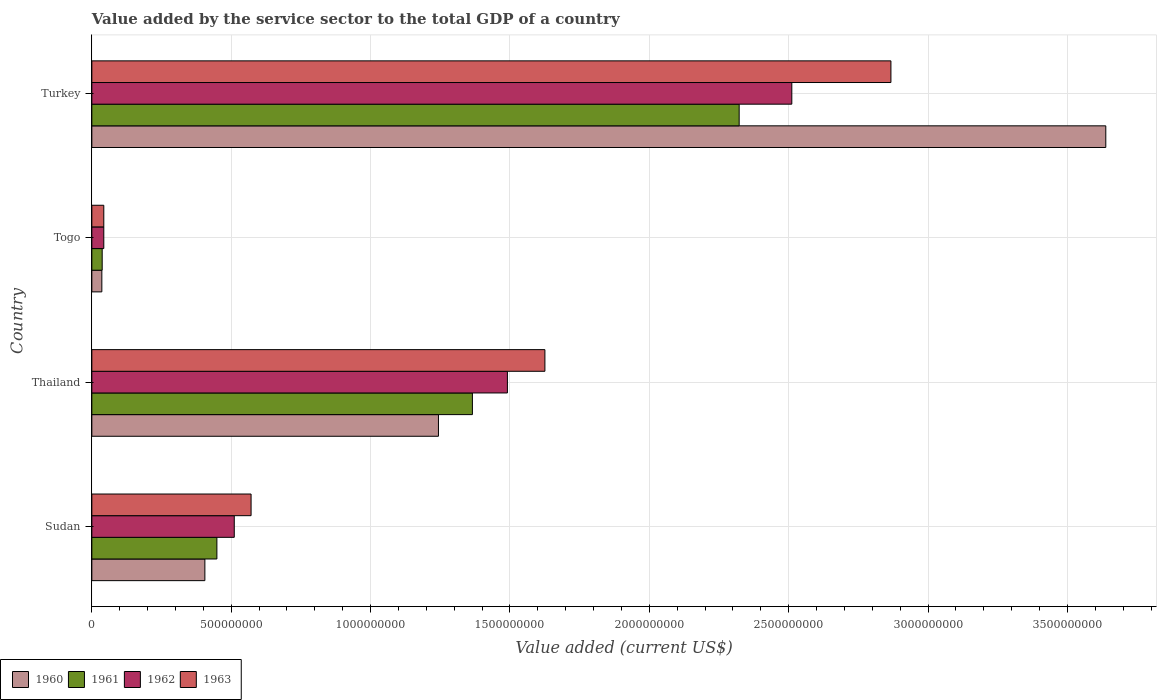How many groups of bars are there?
Provide a succinct answer. 4. Are the number of bars per tick equal to the number of legend labels?
Offer a very short reply. Yes. Are the number of bars on each tick of the Y-axis equal?
Keep it short and to the point. Yes. How many bars are there on the 3rd tick from the top?
Your answer should be compact. 4. How many bars are there on the 1st tick from the bottom?
Your answer should be very brief. 4. What is the label of the 3rd group of bars from the top?
Offer a very short reply. Thailand. What is the value added by the service sector to the total GDP in 1962 in Sudan?
Ensure brevity in your answer.  5.11e+08. Across all countries, what is the maximum value added by the service sector to the total GDP in 1962?
Ensure brevity in your answer.  2.51e+09. Across all countries, what is the minimum value added by the service sector to the total GDP in 1963?
Give a very brief answer. 4.29e+07. In which country was the value added by the service sector to the total GDP in 1961 minimum?
Offer a very short reply. Togo. What is the total value added by the service sector to the total GDP in 1963 in the graph?
Your response must be concise. 5.11e+09. What is the difference between the value added by the service sector to the total GDP in 1961 in Togo and that in Turkey?
Offer a terse response. -2.29e+09. What is the difference between the value added by the service sector to the total GDP in 1962 in Togo and the value added by the service sector to the total GDP in 1960 in Thailand?
Ensure brevity in your answer.  -1.20e+09. What is the average value added by the service sector to the total GDP in 1962 per country?
Make the answer very short. 1.14e+09. What is the difference between the value added by the service sector to the total GDP in 1963 and value added by the service sector to the total GDP in 1961 in Thailand?
Ensure brevity in your answer.  2.60e+08. In how many countries, is the value added by the service sector to the total GDP in 1961 greater than 1200000000 US$?
Give a very brief answer. 2. What is the ratio of the value added by the service sector to the total GDP in 1961 in Thailand to that in Togo?
Your response must be concise. 36.8. Is the difference between the value added by the service sector to the total GDP in 1963 in Sudan and Togo greater than the difference between the value added by the service sector to the total GDP in 1961 in Sudan and Togo?
Keep it short and to the point. Yes. What is the difference between the highest and the second highest value added by the service sector to the total GDP in 1961?
Keep it short and to the point. 9.57e+08. What is the difference between the highest and the lowest value added by the service sector to the total GDP in 1960?
Your answer should be very brief. 3.60e+09. Are the values on the major ticks of X-axis written in scientific E-notation?
Your answer should be compact. No. Does the graph contain grids?
Offer a terse response. Yes. How many legend labels are there?
Your response must be concise. 4. How are the legend labels stacked?
Offer a very short reply. Horizontal. What is the title of the graph?
Offer a very short reply. Value added by the service sector to the total GDP of a country. What is the label or title of the X-axis?
Keep it short and to the point. Value added (current US$). What is the Value added (current US$) in 1960 in Sudan?
Your answer should be very brief. 4.06e+08. What is the Value added (current US$) of 1961 in Sudan?
Your answer should be compact. 4.49e+08. What is the Value added (current US$) of 1962 in Sudan?
Give a very brief answer. 5.11e+08. What is the Value added (current US$) of 1963 in Sudan?
Offer a terse response. 5.71e+08. What is the Value added (current US$) in 1960 in Thailand?
Keep it short and to the point. 1.24e+09. What is the Value added (current US$) of 1961 in Thailand?
Ensure brevity in your answer.  1.37e+09. What is the Value added (current US$) of 1962 in Thailand?
Your response must be concise. 1.49e+09. What is the Value added (current US$) of 1963 in Thailand?
Offer a terse response. 1.63e+09. What is the Value added (current US$) of 1960 in Togo?
Your answer should be compact. 3.59e+07. What is the Value added (current US$) in 1961 in Togo?
Your response must be concise. 3.71e+07. What is the Value added (current US$) in 1962 in Togo?
Keep it short and to the point. 4.29e+07. What is the Value added (current US$) of 1963 in Togo?
Offer a terse response. 4.29e+07. What is the Value added (current US$) of 1960 in Turkey?
Ensure brevity in your answer.  3.64e+09. What is the Value added (current US$) in 1961 in Turkey?
Give a very brief answer. 2.32e+09. What is the Value added (current US$) of 1962 in Turkey?
Ensure brevity in your answer.  2.51e+09. What is the Value added (current US$) in 1963 in Turkey?
Keep it short and to the point. 2.87e+09. Across all countries, what is the maximum Value added (current US$) in 1960?
Give a very brief answer. 3.64e+09. Across all countries, what is the maximum Value added (current US$) in 1961?
Offer a very short reply. 2.32e+09. Across all countries, what is the maximum Value added (current US$) of 1962?
Your answer should be compact. 2.51e+09. Across all countries, what is the maximum Value added (current US$) of 1963?
Your answer should be very brief. 2.87e+09. Across all countries, what is the minimum Value added (current US$) in 1960?
Ensure brevity in your answer.  3.59e+07. Across all countries, what is the minimum Value added (current US$) in 1961?
Offer a very short reply. 3.71e+07. Across all countries, what is the minimum Value added (current US$) of 1962?
Provide a succinct answer. 4.29e+07. Across all countries, what is the minimum Value added (current US$) of 1963?
Your answer should be compact. 4.29e+07. What is the total Value added (current US$) in 1960 in the graph?
Your response must be concise. 5.32e+09. What is the total Value added (current US$) in 1961 in the graph?
Keep it short and to the point. 4.17e+09. What is the total Value added (current US$) of 1962 in the graph?
Provide a succinct answer. 4.56e+09. What is the total Value added (current US$) in 1963 in the graph?
Give a very brief answer. 5.11e+09. What is the difference between the Value added (current US$) of 1960 in Sudan and that in Thailand?
Give a very brief answer. -8.38e+08. What is the difference between the Value added (current US$) of 1961 in Sudan and that in Thailand?
Provide a short and direct response. -9.17e+08. What is the difference between the Value added (current US$) in 1962 in Sudan and that in Thailand?
Ensure brevity in your answer.  -9.80e+08. What is the difference between the Value added (current US$) of 1963 in Sudan and that in Thailand?
Provide a short and direct response. -1.05e+09. What is the difference between the Value added (current US$) in 1960 in Sudan and that in Togo?
Provide a short and direct response. 3.70e+08. What is the difference between the Value added (current US$) of 1961 in Sudan and that in Togo?
Your answer should be compact. 4.11e+08. What is the difference between the Value added (current US$) in 1962 in Sudan and that in Togo?
Your response must be concise. 4.68e+08. What is the difference between the Value added (current US$) of 1963 in Sudan and that in Togo?
Provide a succinct answer. 5.28e+08. What is the difference between the Value added (current US$) in 1960 in Sudan and that in Turkey?
Your response must be concise. -3.23e+09. What is the difference between the Value added (current US$) of 1961 in Sudan and that in Turkey?
Make the answer very short. -1.87e+09. What is the difference between the Value added (current US$) in 1962 in Sudan and that in Turkey?
Your answer should be compact. -2.00e+09. What is the difference between the Value added (current US$) of 1963 in Sudan and that in Turkey?
Provide a succinct answer. -2.30e+09. What is the difference between the Value added (current US$) in 1960 in Thailand and that in Togo?
Your response must be concise. 1.21e+09. What is the difference between the Value added (current US$) of 1961 in Thailand and that in Togo?
Provide a succinct answer. 1.33e+09. What is the difference between the Value added (current US$) of 1962 in Thailand and that in Togo?
Your response must be concise. 1.45e+09. What is the difference between the Value added (current US$) in 1963 in Thailand and that in Togo?
Your response must be concise. 1.58e+09. What is the difference between the Value added (current US$) in 1960 in Thailand and that in Turkey?
Provide a short and direct response. -2.39e+09. What is the difference between the Value added (current US$) of 1961 in Thailand and that in Turkey?
Offer a very short reply. -9.57e+08. What is the difference between the Value added (current US$) of 1962 in Thailand and that in Turkey?
Your response must be concise. -1.02e+09. What is the difference between the Value added (current US$) of 1963 in Thailand and that in Turkey?
Make the answer very short. -1.24e+09. What is the difference between the Value added (current US$) of 1960 in Togo and that in Turkey?
Offer a very short reply. -3.60e+09. What is the difference between the Value added (current US$) in 1961 in Togo and that in Turkey?
Ensure brevity in your answer.  -2.29e+09. What is the difference between the Value added (current US$) of 1962 in Togo and that in Turkey?
Make the answer very short. -2.47e+09. What is the difference between the Value added (current US$) in 1963 in Togo and that in Turkey?
Provide a short and direct response. -2.82e+09. What is the difference between the Value added (current US$) of 1960 in Sudan and the Value added (current US$) of 1961 in Thailand?
Your response must be concise. -9.60e+08. What is the difference between the Value added (current US$) in 1960 in Sudan and the Value added (current US$) in 1962 in Thailand?
Your answer should be compact. -1.09e+09. What is the difference between the Value added (current US$) of 1960 in Sudan and the Value added (current US$) of 1963 in Thailand?
Offer a terse response. -1.22e+09. What is the difference between the Value added (current US$) in 1961 in Sudan and the Value added (current US$) in 1962 in Thailand?
Your answer should be compact. -1.04e+09. What is the difference between the Value added (current US$) in 1961 in Sudan and the Value added (current US$) in 1963 in Thailand?
Provide a succinct answer. -1.18e+09. What is the difference between the Value added (current US$) of 1962 in Sudan and the Value added (current US$) of 1963 in Thailand?
Provide a succinct answer. -1.11e+09. What is the difference between the Value added (current US$) of 1960 in Sudan and the Value added (current US$) of 1961 in Togo?
Provide a succinct answer. 3.68e+08. What is the difference between the Value added (current US$) of 1960 in Sudan and the Value added (current US$) of 1962 in Togo?
Ensure brevity in your answer.  3.63e+08. What is the difference between the Value added (current US$) in 1960 in Sudan and the Value added (current US$) in 1963 in Togo?
Offer a terse response. 3.63e+08. What is the difference between the Value added (current US$) of 1961 in Sudan and the Value added (current US$) of 1962 in Togo?
Provide a short and direct response. 4.06e+08. What is the difference between the Value added (current US$) of 1961 in Sudan and the Value added (current US$) of 1963 in Togo?
Offer a terse response. 4.06e+08. What is the difference between the Value added (current US$) in 1962 in Sudan and the Value added (current US$) in 1963 in Togo?
Your response must be concise. 4.68e+08. What is the difference between the Value added (current US$) of 1960 in Sudan and the Value added (current US$) of 1961 in Turkey?
Keep it short and to the point. -1.92e+09. What is the difference between the Value added (current US$) in 1960 in Sudan and the Value added (current US$) in 1962 in Turkey?
Keep it short and to the point. -2.11e+09. What is the difference between the Value added (current US$) of 1960 in Sudan and the Value added (current US$) of 1963 in Turkey?
Your response must be concise. -2.46e+09. What is the difference between the Value added (current US$) in 1961 in Sudan and the Value added (current US$) in 1962 in Turkey?
Offer a very short reply. -2.06e+09. What is the difference between the Value added (current US$) of 1961 in Sudan and the Value added (current US$) of 1963 in Turkey?
Offer a terse response. -2.42e+09. What is the difference between the Value added (current US$) in 1962 in Sudan and the Value added (current US$) in 1963 in Turkey?
Provide a short and direct response. -2.36e+09. What is the difference between the Value added (current US$) of 1960 in Thailand and the Value added (current US$) of 1961 in Togo?
Provide a succinct answer. 1.21e+09. What is the difference between the Value added (current US$) of 1960 in Thailand and the Value added (current US$) of 1962 in Togo?
Your answer should be compact. 1.20e+09. What is the difference between the Value added (current US$) of 1960 in Thailand and the Value added (current US$) of 1963 in Togo?
Keep it short and to the point. 1.20e+09. What is the difference between the Value added (current US$) in 1961 in Thailand and the Value added (current US$) in 1962 in Togo?
Ensure brevity in your answer.  1.32e+09. What is the difference between the Value added (current US$) of 1961 in Thailand and the Value added (current US$) of 1963 in Togo?
Your answer should be compact. 1.32e+09. What is the difference between the Value added (current US$) in 1962 in Thailand and the Value added (current US$) in 1963 in Togo?
Keep it short and to the point. 1.45e+09. What is the difference between the Value added (current US$) of 1960 in Thailand and the Value added (current US$) of 1961 in Turkey?
Your answer should be very brief. -1.08e+09. What is the difference between the Value added (current US$) in 1960 in Thailand and the Value added (current US$) in 1962 in Turkey?
Provide a succinct answer. -1.27e+09. What is the difference between the Value added (current US$) of 1960 in Thailand and the Value added (current US$) of 1963 in Turkey?
Your response must be concise. -1.62e+09. What is the difference between the Value added (current US$) of 1961 in Thailand and the Value added (current US$) of 1962 in Turkey?
Offer a very short reply. -1.15e+09. What is the difference between the Value added (current US$) in 1961 in Thailand and the Value added (current US$) in 1963 in Turkey?
Keep it short and to the point. -1.50e+09. What is the difference between the Value added (current US$) of 1962 in Thailand and the Value added (current US$) of 1963 in Turkey?
Your response must be concise. -1.38e+09. What is the difference between the Value added (current US$) of 1960 in Togo and the Value added (current US$) of 1961 in Turkey?
Keep it short and to the point. -2.29e+09. What is the difference between the Value added (current US$) in 1960 in Togo and the Value added (current US$) in 1962 in Turkey?
Provide a short and direct response. -2.48e+09. What is the difference between the Value added (current US$) of 1960 in Togo and the Value added (current US$) of 1963 in Turkey?
Ensure brevity in your answer.  -2.83e+09. What is the difference between the Value added (current US$) of 1961 in Togo and the Value added (current US$) of 1962 in Turkey?
Make the answer very short. -2.47e+09. What is the difference between the Value added (current US$) of 1961 in Togo and the Value added (current US$) of 1963 in Turkey?
Your answer should be compact. -2.83e+09. What is the difference between the Value added (current US$) in 1962 in Togo and the Value added (current US$) in 1963 in Turkey?
Your answer should be very brief. -2.82e+09. What is the average Value added (current US$) of 1960 per country?
Offer a very short reply. 1.33e+09. What is the average Value added (current US$) of 1961 per country?
Your response must be concise. 1.04e+09. What is the average Value added (current US$) in 1962 per country?
Make the answer very short. 1.14e+09. What is the average Value added (current US$) of 1963 per country?
Offer a terse response. 1.28e+09. What is the difference between the Value added (current US$) of 1960 and Value added (current US$) of 1961 in Sudan?
Offer a terse response. -4.31e+07. What is the difference between the Value added (current US$) in 1960 and Value added (current US$) in 1962 in Sudan?
Your answer should be very brief. -1.05e+08. What is the difference between the Value added (current US$) of 1960 and Value added (current US$) of 1963 in Sudan?
Provide a succinct answer. -1.66e+08. What is the difference between the Value added (current US$) in 1961 and Value added (current US$) in 1962 in Sudan?
Your response must be concise. -6.23e+07. What is the difference between the Value added (current US$) of 1961 and Value added (current US$) of 1963 in Sudan?
Offer a terse response. -1.23e+08. What is the difference between the Value added (current US$) of 1962 and Value added (current US$) of 1963 in Sudan?
Keep it short and to the point. -6.03e+07. What is the difference between the Value added (current US$) of 1960 and Value added (current US$) of 1961 in Thailand?
Give a very brief answer. -1.22e+08. What is the difference between the Value added (current US$) of 1960 and Value added (current US$) of 1962 in Thailand?
Keep it short and to the point. -2.47e+08. What is the difference between the Value added (current US$) in 1960 and Value added (current US$) in 1963 in Thailand?
Offer a very short reply. -3.82e+08. What is the difference between the Value added (current US$) in 1961 and Value added (current US$) in 1962 in Thailand?
Keep it short and to the point. -1.26e+08. What is the difference between the Value added (current US$) in 1961 and Value added (current US$) in 1963 in Thailand?
Your answer should be very brief. -2.60e+08. What is the difference between the Value added (current US$) of 1962 and Value added (current US$) of 1963 in Thailand?
Your answer should be compact. -1.35e+08. What is the difference between the Value added (current US$) in 1960 and Value added (current US$) in 1961 in Togo?
Ensure brevity in your answer.  -1.21e+06. What is the difference between the Value added (current US$) in 1960 and Value added (current US$) in 1962 in Togo?
Offer a terse response. -6.96e+06. What is the difference between the Value added (current US$) of 1960 and Value added (current US$) of 1963 in Togo?
Ensure brevity in your answer.  -6.96e+06. What is the difference between the Value added (current US$) in 1961 and Value added (current US$) in 1962 in Togo?
Ensure brevity in your answer.  -5.75e+06. What is the difference between the Value added (current US$) of 1961 and Value added (current US$) of 1963 in Togo?
Offer a very short reply. -5.75e+06. What is the difference between the Value added (current US$) in 1962 and Value added (current US$) in 1963 in Togo?
Your response must be concise. 370.33. What is the difference between the Value added (current US$) of 1960 and Value added (current US$) of 1961 in Turkey?
Keep it short and to the point. 1.32e+09. What is the difference between the Value added (current US$) in 1960 and Value added (current US$) in 1962 in Turkey?
Ensure brevity in your answer.  1.13e+09. What is the difference between the Value added (current US$) in 1960 and Value added (current US$) in 1963 in Turkey?
Your answer should be compact. 7.71e+08. What is the difference between the Value added (current US$) in 1961 and Value added (current US$) in 1962 in Turkey?
Keep it short and to the point. -1.89e+08. What is the difference between the Value added (current US$) in 1961 and Value added (current US$) in 1963 in Turkey?
Keep it short and to the point. -5.44e+08. What is the difference between the Value added (current US$) of 1962 and Value added (current US$) of 1963 in Turkey?
Make the answer very short. -3.56e+08. What is the ratio of the Value added (current US$) of 1960 in Sudan to that in Thailand?
Your answer should be compact. 0.33. What is the ratio of the Value added (current US$) in 1961 in Sudan to that in Thailand?
Provide a short and direct response. 0.33. What is the ratio of the Value added (current US$) in 1962 in Sudan to that in Thailand?
Offer a very short reply. 0.34. What is the ratio of the Value added (current US$) in 1963 in Sudan to that in Thailand?
Provide a succinct answer. 0.35. What is the ratio of the Value added (current US$) of 1960 in Sudan to that in Togo?
Your answer should be very brief. 11.3. What is the ratio of the Value added (current US$) in 1961 in Sudan to that in Togo?
Give a very brief answer. 12.09. What is the ratio of the Value added (current US$) of 1962 in Sudan to that in Togo?
Make the answer very short. 11.92. What is the ratio of the Value added (current US$) in 1963 in Sudan to that in Togo?
Your answer should be compact. 13.33. What is the ratio of the Value added (current US$) of 1960 in Sudan to that in Turkey?
Ensure brevity in your answer.  0.11. What is the ratio of the Value added (current US$) in 1961 in Sudan to that in Turkey?
Provide a succinct answer. 0.19. What is the ratio of the Value added (current US$) in 1962 in Sudan to that in Turkey?
Your response must be concise. 0.2. What is the ratio of the Value added (current US$) of 1963 in Sudan to that in Turkey?
Ensure brevity in your answer.  0.2. What is the ratio of the Value added (current US$) of 1960 in Thailand to that in Togo?
Make the answer very short. 34.65. What is the ratio of the Value added (current US$) in 1961 in Thailand to that in Togo?
Provide a succinct answer. 36.8. What is the ratio of the Value added (current US$) in 1962 in Thailand to that in Togo?
Offer a very short reply. 34.79. What is the ratio of the Value added (current US$) of 1963 in Thailand to that in Togo?
Your answer should be compact. 37.93. What is the ratio of the Value added (current US$) of 1960 in Thailand to that in Turkey?
Your answer should be very brief. 0.34. What is the ratio of the Value added (current US$) of 1961 in Thailand to that in Turkey?
Your answer should be compact. 0.59. What is the ratio of the Value added (current US$) in 1962 in Thailand to that in Turkey?
Your answer should be very brief. 0.59. What is the ratio of the Value added (current US$) of 1963 in Thailand to that in Turkey?
Your answer should be very brief. 0.57. What is the ratio of the Value added (current US$) of 1960 in Togo to that in Turkey?
Give a very brief answer. 0.01. What is the ratio of the Value added (current US$) in 1961 in Togo to that in Turkey?
Ensure brevity in your answer.  0.02. What is the ratio of the Value added (current US$) in 1962 in Togo to that in Turkey?
Offer a very short reply. 0.02. What is the ratio of the Value added (current US$) of 1963 in Togo to that in Turkey?
Ensure brevity in your answer.  0.01. What is the difference between the highest and the second highest Value added (current US$) in 1960?
Ensure brevity in your answer.  2.39e+09. What is the difference between the highest and the second highest Value added (current US$) in 1961?
Your response must be concise. 9.57e+08. What is the difference between the highest and the second highest Value added (current US$) in 1962?
Offer a very short reply. 1.02e+09. What is the difference between the highest and the second highest Value added (current US$) of 1963?
Provide a short and direct response. 1.24e+09. What is the difference between the highest and the lowest Value added (current US$) of 1960?
Your answer should be compact. 3.60e+09. What is the difference between the highest and the lowest Value added (current US$) of 1961?
Provide a short and direct response. 2.29e+09. What is the difference between the highest and the lowest Value added (current US$) of 1962?
Provide a succinct answer. 2.47e+09. What is the difference between the highest and the lowest Value added (current US$) in 1963?
Provide a succinct answer. 2.82e+09. 